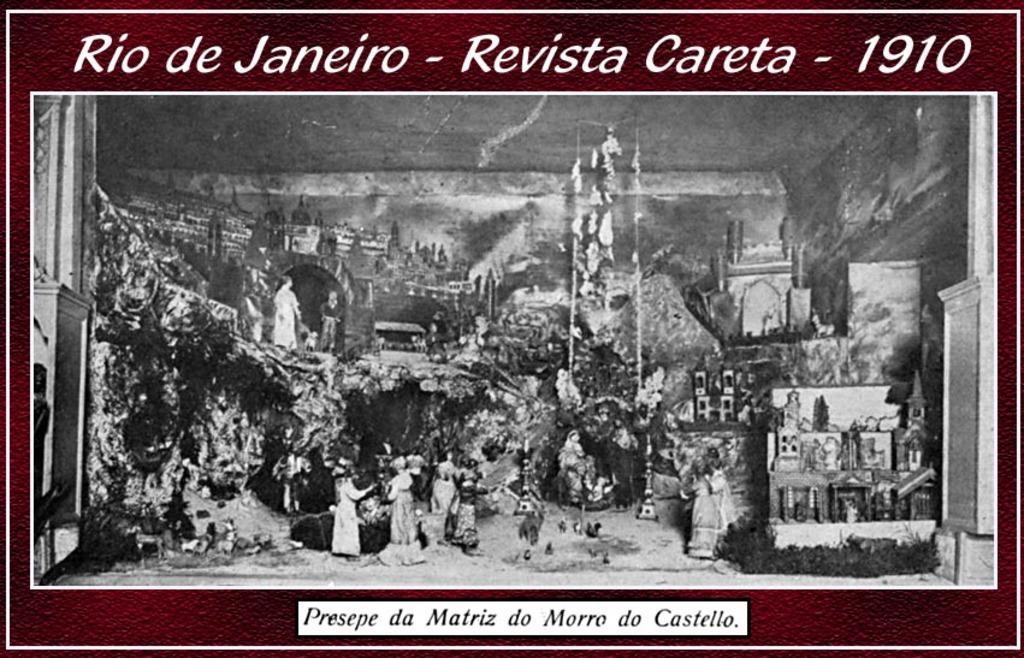Please provide a concise description of this image. In this image we can see there is an old photo and something is written on it. It says Rio de Janeiro revista Careta 1910. 